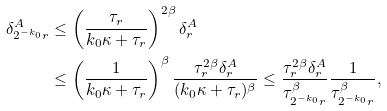Convert formula to latex. <formula><loc_0><loc_0><loc_500><loc_500>\delta ^ { A } _ { 2 ^ { - k _ { 0 } } r } & \leq \left ( \frac { \tau _ { r } } { k _ { 0 } \kappa + \tau _ { r } } \right ) ^ { 2 \beta } \delta ^ { A } _ { r } \\ & \leq \left ( \frac { 1 } { k _ { 0 } \kappa + \tau _ { r } } \right ) ^ { \beta } \frac { \tau _ { r } ^ { 2 \beta } \delta ^ { A } _ { r } } { ( k _ { 0 } \kappa + \tau _ { r } ) ^ { \beta } } \leq \frac { \tau _ { r } ^ { 2 \beta } \delta ^ { A } _ { r } } { \tau _ { 2 ^ { - k _ { 0 } } r } ^ { \beta } } \frac { 1 } { \tau _ { 2 ^ { - k _ { 0 } } r } ^ { \beta } } ,</formula> 